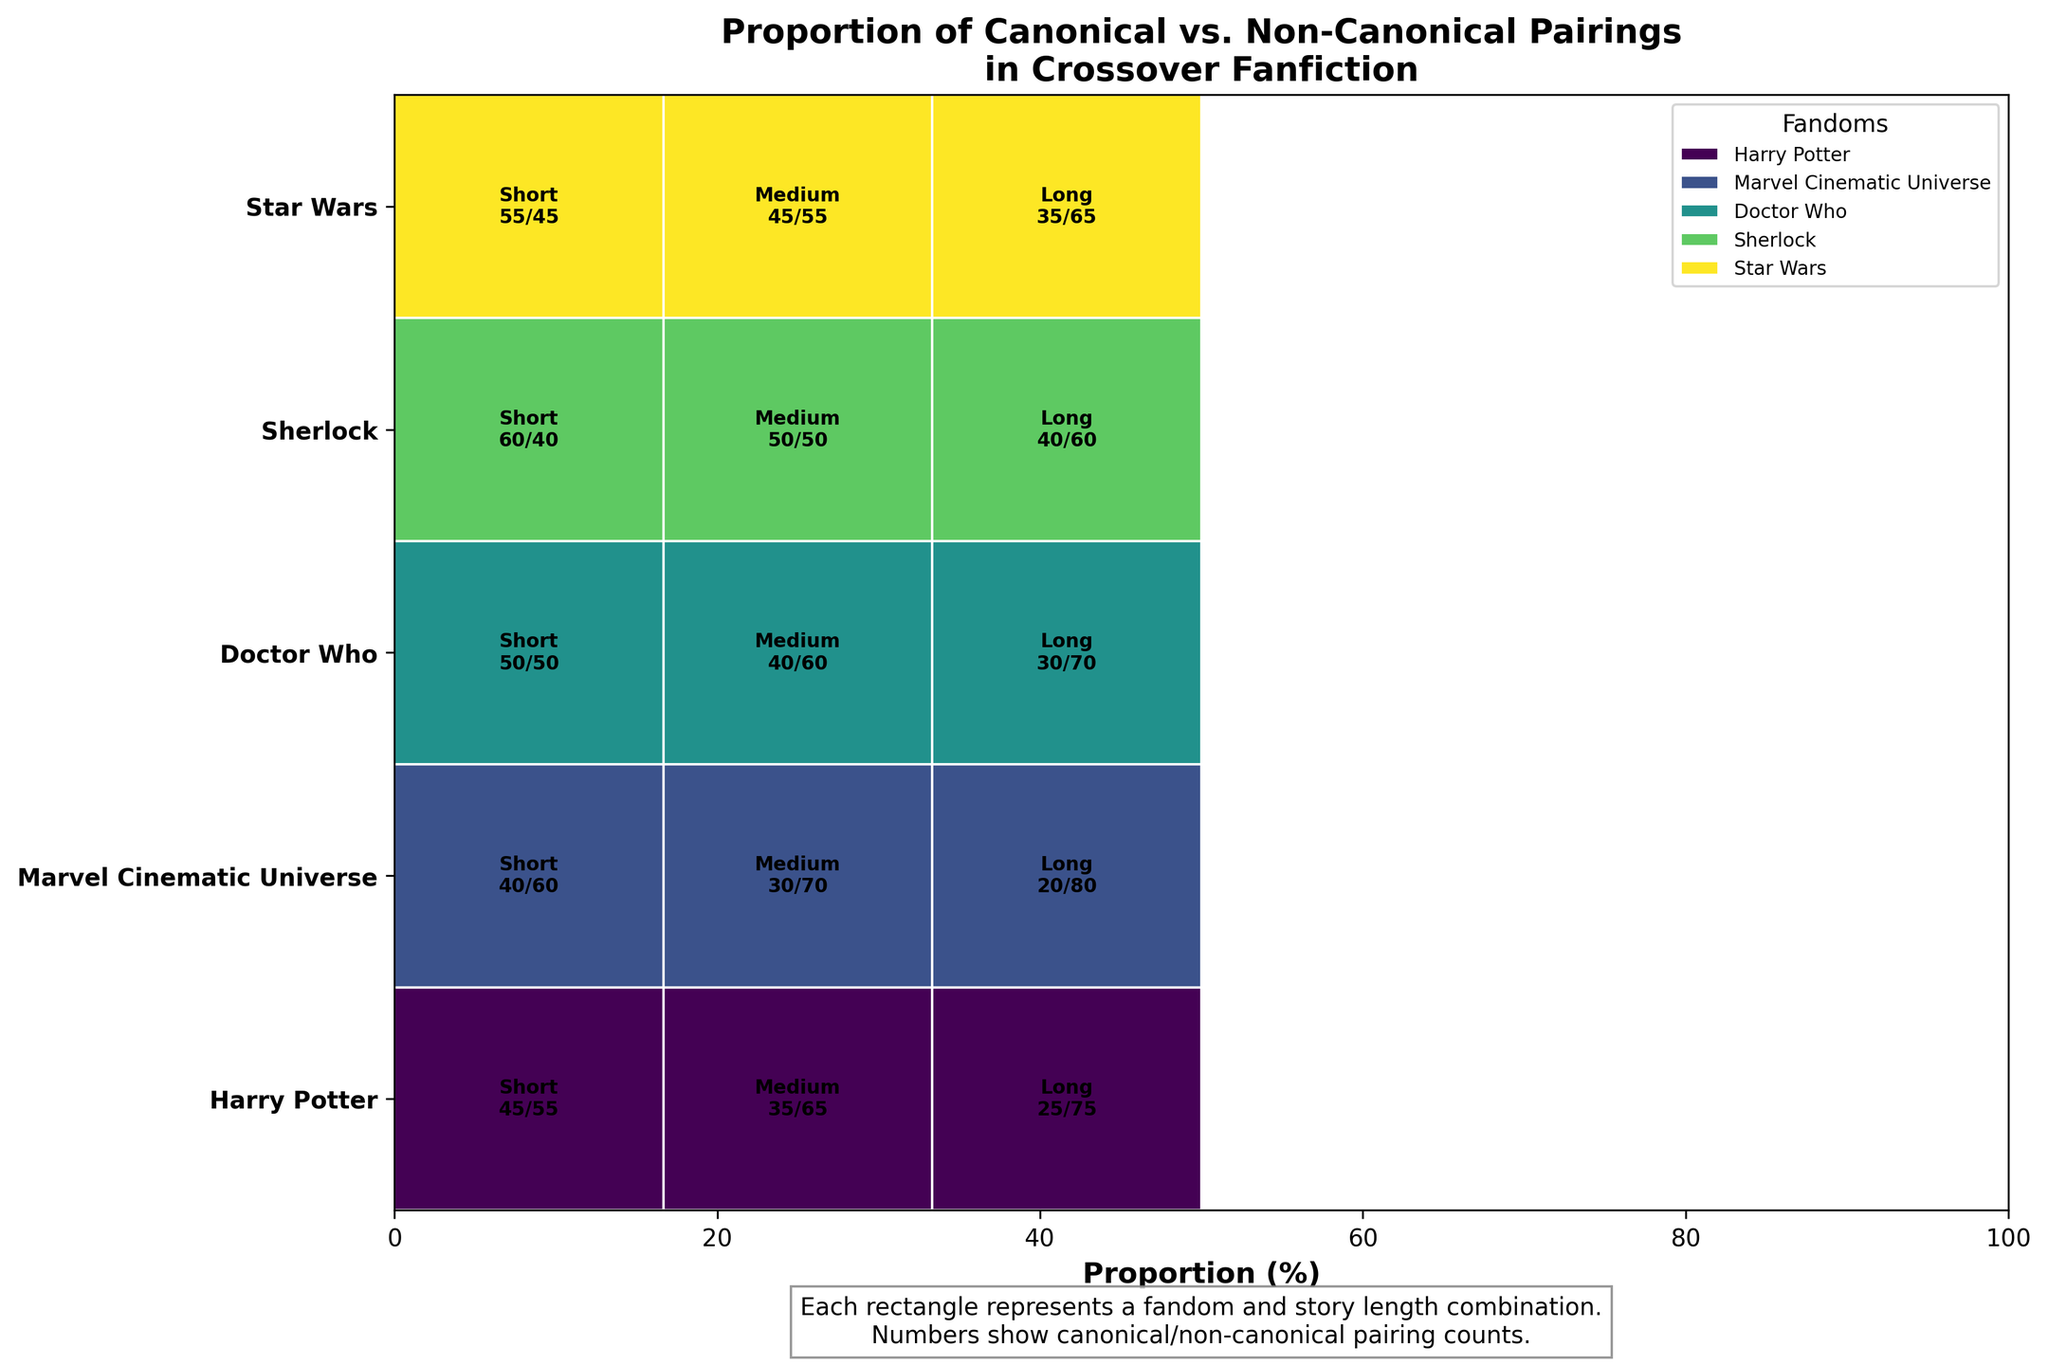What is the title of the plot? The title of the plot is usually displayed prominently at the top of the figure. In this case, the title is "Proportion of Canonical vs. Non-Canonical Pairings in Crossover Fanfiction".
Answer: Proportion of Canonical vs. Non-Canonical Pairings in Crossover Fanfiction Which fandom has the highest proportion of canonical pairings for short stories? To find this, look at the short stories section and compare the counts of canonical pairings for each fandom. The numbers indicate that Sherlock has the highest proportion of canonical pairings (60%).
Answer: Sherlock What is the trend in canonical pairings for the Harry Potter fandom as story length increases? Examine the Harry Potter fandom row and notice the proportion of canonical pairings for short (45), medium (35), and long stories (25). The pattern shows a decreasing trend in canonical pairings as story length increases.
Answer: Decreasing Which pair of fandom and story length results in an equal number of canonical and non-canonical pairings? Look at the plot for any pair of fandom and story length where the counts of canonical and non-canonical are the same. The plot shows that the short stories of Doctor Who have equal canonical and non-canonical pairings (50% each).
Answer: Doctor Who, Short Comparing Star Wars and Marvel Cinematic Universe, which has a higher proportion of non-canonical pairings in long stories? For long stories, compare the proportion of non-canonical pairings for Star Wars (65%) and Marvel Cinematic Universe (80%). The Marvel Cinematic Universe has a higher proportion.
Answer: Marvel Cinematic Universe How does the proportion of non-canonical pairings in short stories compare between Star Wars and Sherlock? For short stories, look at Star Wars (45%) and Sherlock (40%). Star Wars has a higher proportion of non-canonical pairings compared to Sherlock.
Answer: Star Wars What is the total number of canonical pairings for the Doctor Who fandom across all story lengths? Sum the canonical pairings for all story lengths in Doctor Who: short (50), medium (40), and long (30). This results in 50 + 40 + 30 = 120 canonical pairings.
Answer: 120 How do the canonical and non-canonical pairings in medium-length stories for Star Wars compare? For medium-length stories in Star Wars, compare the counts of canonical pairings (45) with non-canonical pairings (55). Non-canonical pairings are higher.
Answer: Non-canonical pairings are higher Which fandom shows the most significant difference between canonical and non-canonical pairings in long stories? For long stories, calculate the differences between canonical and non-canonical pairings for each fandom: Harry Potter (50), Marvel Cinematic Universe (60), Doctor Who (40), Sherlock (20), Star Wars (30). Marvel Cinematic Universe shows the largest difference.
Answer: Marvel Cinematic Universe What is the average proportion of canonical pairings across all story lengths for the Marvel Cinematic Universe? The canonical pairings for Marvel Cinematic Universe are short (40), medium (30), and long (20). Sum these up 40 + 30 + 20 = 90 and divide by 3 to get the average: 90 / 3 = 30%.
Answer: 30% 